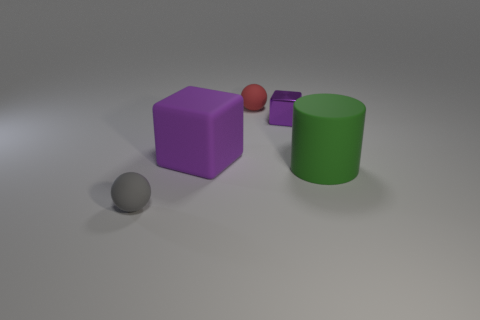Add 4 small gray matte balls. How many objects exist? 9 Subtract all cylinders. How many objects are left? 4 Subtract 0 yellow balls. How many objects are left? 5 Subtract all large purple blocks. Subtract all small gray objects. How many objects are left? 3 Add 5 large purple blocks. How many large purple blocks are left? 6 Add 5 purple balls. How many purple balls exist? 5 